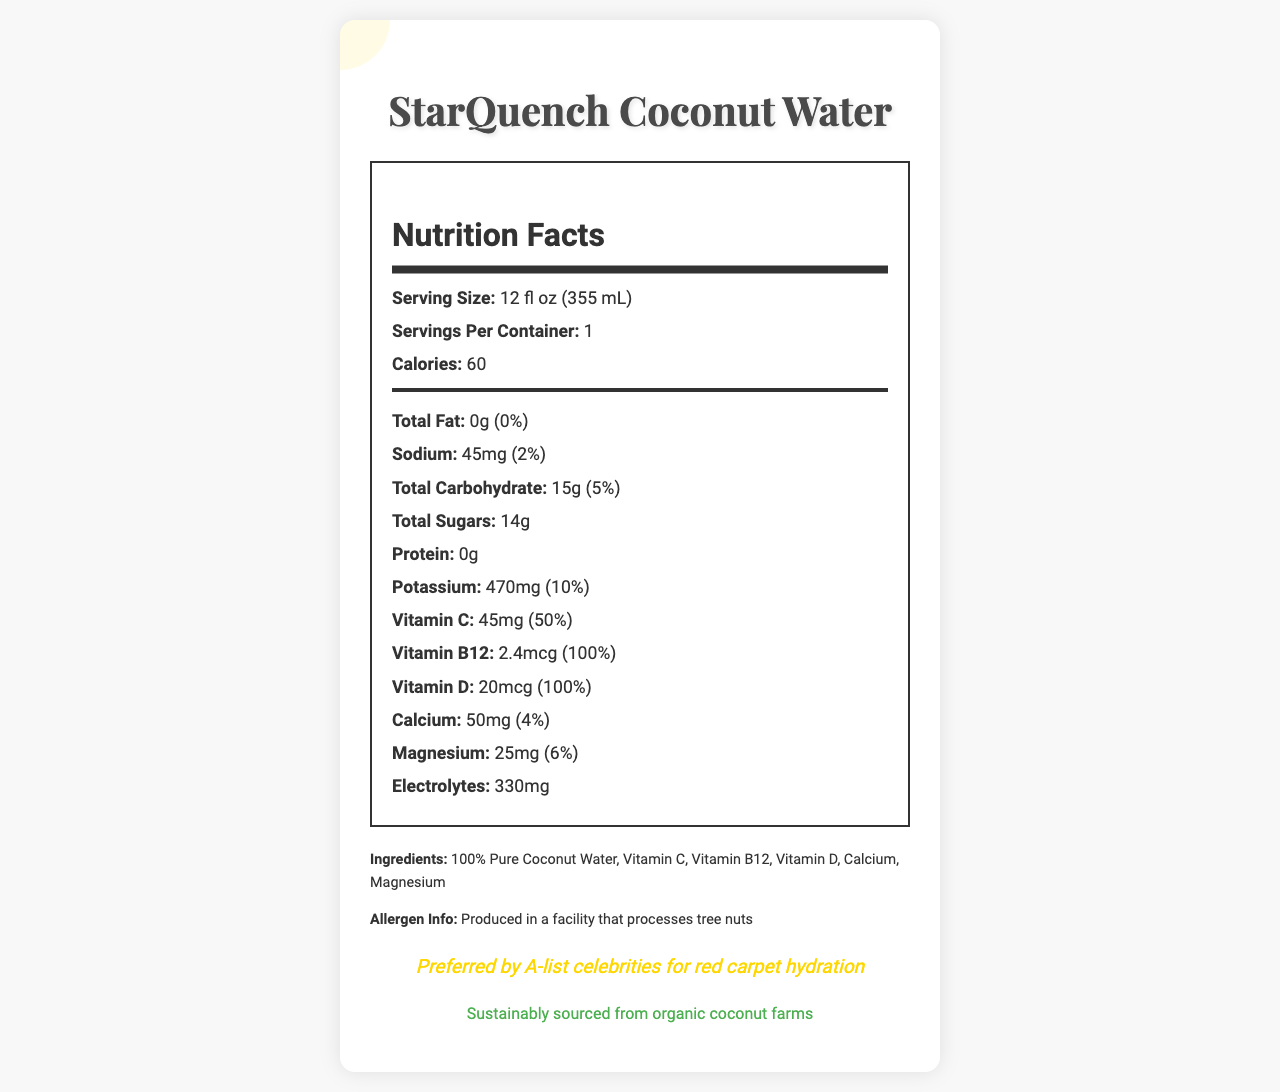what is the serving size of StarQuench Coconut Water? The serving size is clearly mentioned at the top of the nutrition information as "12 fl oz (355 mL)."
Answer: 12 fl oz (355 mL) how much potassium does one serving contain? The amount of potassium per serving is listed under the nutrition facts as "470mg."
Answer: 470mg how many calories are in one serving? The calorie content per serving is stated prominently in the nutrition facts section as "60."
Answer: 60 what percentage of the daily value of Vitamin D is provided by one serving? Under the nutrition facts, the daily value percentage for Vitamin D is listed as "100%."
Answer: 100% what is the total amount of sugars in one serving? The total sugar content can be found in the nutrition facts section as "14g."
Answer: 14g which vitamins are included in StarQuench Coconut Water? A. Vitamin C and Vitamin A B. Vitamin C and Vitamin B12 C. Vitamin A and Vitamin D D. Vitamin C and Vitamin E The document lists Vitamin C and Vitamin B12 under the nutritional information.
Answer: B. Vitamin C and Vitamin B12 what is the daily value percentage for calcium provided by one serving? A. 2% B. 4% C. 6% D. 10% The daily value percentage for calcium is listed under the nutritional information as "4%."
Answer: B. 4% is the StarQuench Coconut Water bottle eco-friendly? The document states that the packaging is "BPA-free, recyclable bottle" and that it is "Sustainably sourced from organic coconut farms."
Answer: Yes does StarQuench Coconut Water contain any fat? The nutrition facts label lists the total fat content as "0g," which also means "0% daily value," indicating it contains no fat.
Answer: No summarize the main features of StarQuench Coconut Water. The document highlights the product's vitamins, electrolytes, sustainability, and endorsement by celebrities, capturing the essence and features of the beverage.
Answer: StarQuench Coconut Water is a vitamin-enriched beverage popular among celebrities, offering hydration with essential vitamins and electrolytes. It is sustainably sourced and comes in eco-friendly packaging. what is the origin of StarQuench's popularity? The brand story explains that StarQuench was discovered by a rising Hollywood star during a tropical film shoot, leading to its popularity among the entertainment elite.
Answer: Discovered by a rising Hollywood star during a tropical film shoot how long is the shelf life of StarQuench Coconut Water after opening? The document specifies that the shelf life after opening is "5 days."
Answer: 5 days how many servings are there per container of StarQuench Coconut Water? The serving size section indicates there is "1 serving per container."
Answer: 1 does StarQuench Coconut Water contain protein? The nutrition facts clearly list the protein content as "0g."
Answer: No are there any allergens associated with StarQuench Coconut Water? The allergen information states that it is produced in a facility that processes tree nuts.
Answer: Produced in a facility that processes tree nuts which ingredient is listed first in StarQuench Coconut Water? The ingredients section lists "100% Pure Coconut Water" as the first ingredient.
Answer: 100% Pure Coconut Water what is the electrolyte content of StarQuench Coconut Water? The nutrition facts section lists the electrolyte content as "330mg."
Answer: 330mg is there any information about where StarQuench Coconut Water is distributed? The document mentions that it is available at exclusive Hollywood events and select high-end retailers.
Answer: Available at exclusive Hollywood events and select high-end retailers what is the amount of magnesium per serving? The nutrition facts indicate that one serving contains "25mg" of magnesium.
Answer: 25mg how long can an unopened StarQuench Coconut Water be stored? The document states that the shelf life of an unopened bottle is "12 months."
Answer: 12 months why is StarQuench Coconut Water preferred by celebrities? The document mentions that it is "Preferred by A-list celebrities for red carpet hydration."
Answer: Preferred by A-list celebrities for red carpet hydration what is the suggested daily value percentage for sodium in StarQuench Coconut Water? The daily value percentage for sodium is listed in the nutrition facts section as "2%."
Answer: 2% what is the primary source of the vitamins in StarQuench Coconut Water? The document does not provide specific information about the primary source of the vitamins.
Answer: Cannot be determined 